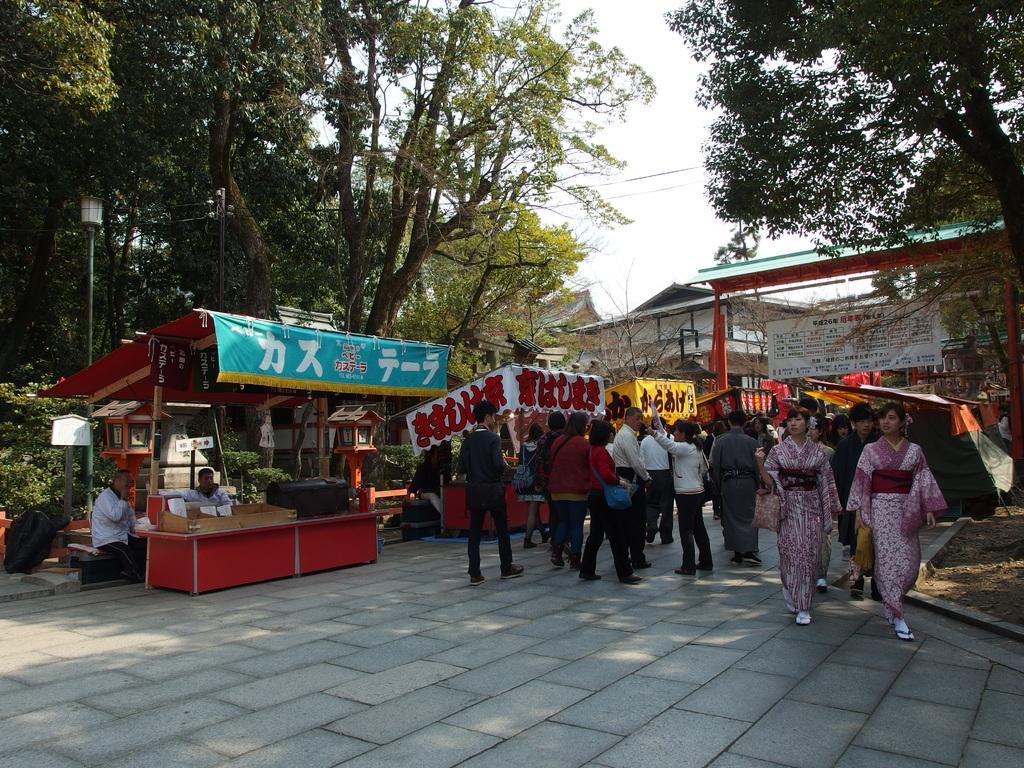Can you describe this image briefly? This image is taken outdoors. At the bottom of the image there is a floor. On the right side of the image there are a few stalls and boards with them and there are a few trees. At the top of the image there is a sky. On the left side of the image there are a few trees and stalls with boards and text on them. In the middle of the image a few people are walking on the floor. In the background there is a house. 